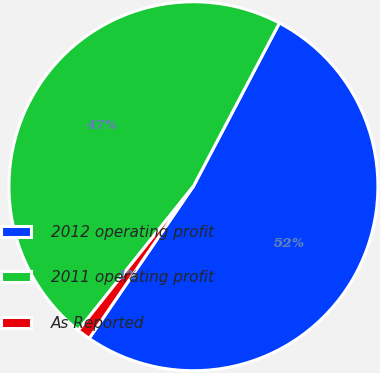<chart> <loc_0><loc_0><loc_500><loc_500><pie_chart><fcel>2012 operating profit<fcel>2011 operating profit<fcel>As Reported<nl><fcel>51.85%<fcel>46.99%<fcel>1.17%<nl></chart> 